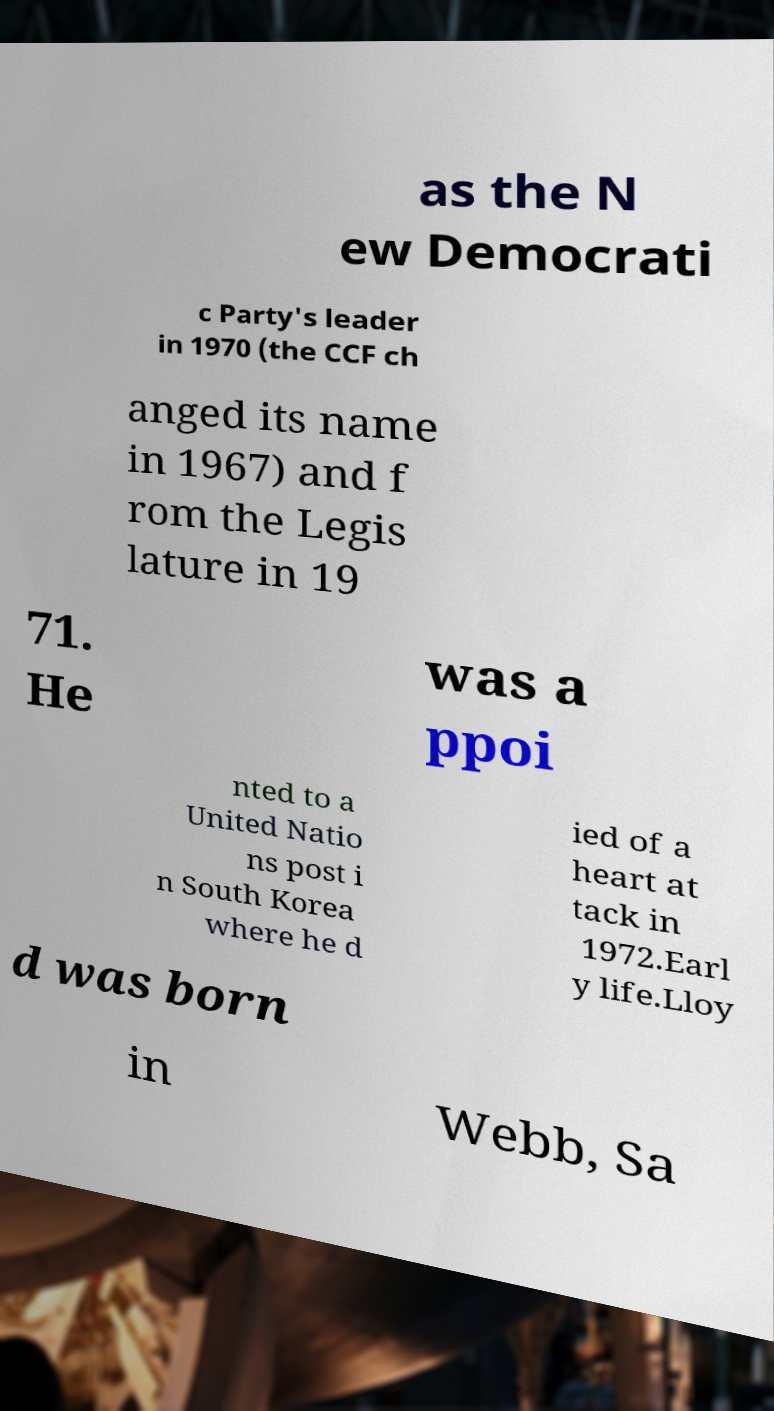For documentation purposes, I need the text within this image transcribed. Could you provide that? as the N ew Democrati c Party's leader in 1970 (the CCF ch anged its name in 1967) and f rom the Legis lature in 19 71. He was a ppoi nted to a United Natio ns post i n South Korea where he d ied of a heart at tack in 1972.Earl y life.Lloy d was born in Webb, Sa 